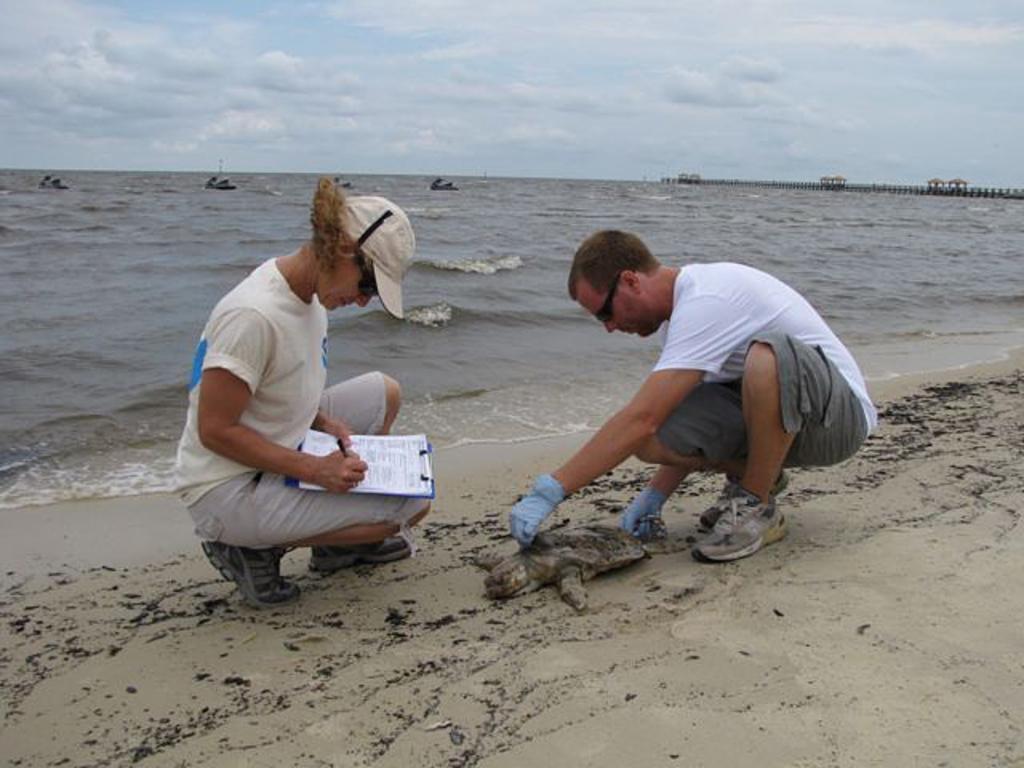Could you give a brief overview of what you see in this image? In this image, we can see two people are wearing glasses. Here a person is holding a pad with papers. Background we can see the sea. Top of the image, there is a sky. 